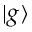<formula> <loc_0><loc_0><loc_500><loc_500>| g \rangle</formula> 